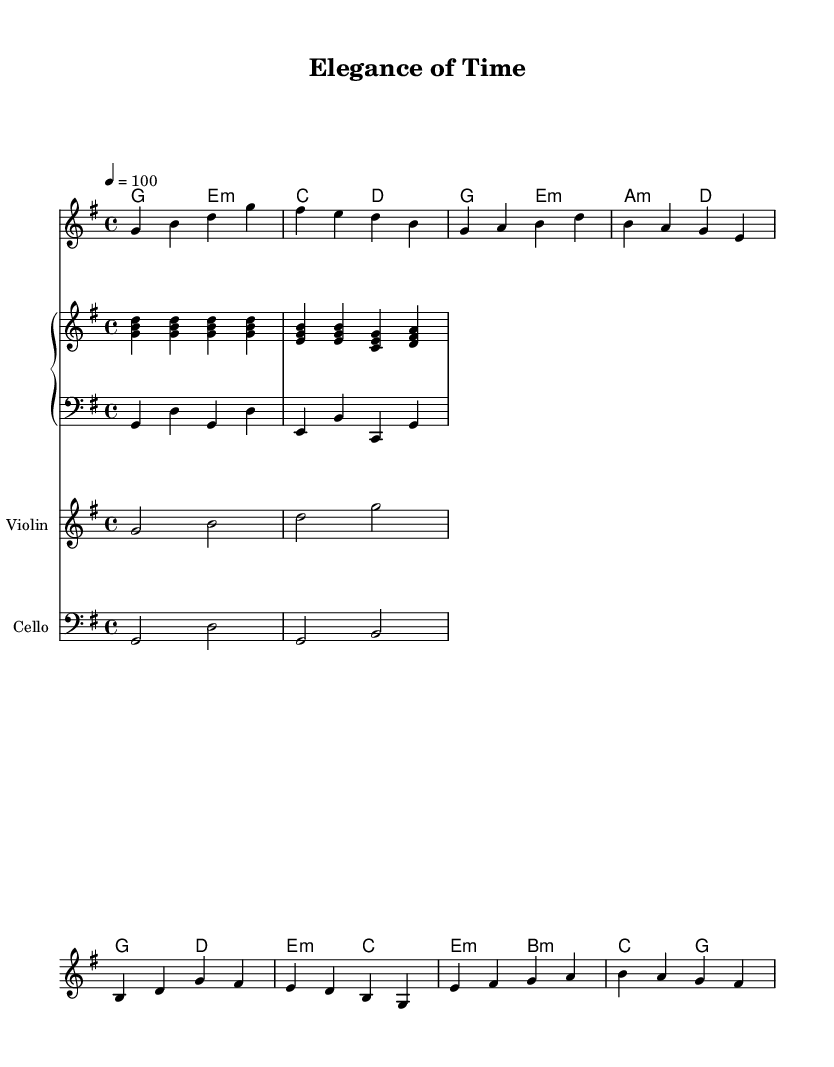What is the key signature of this music? The key signature indicates the presence of one sharp (F#), which means the music is in G major.
Answer: G major What is the time signature of this music? The time signature shows a 4/4 indication, meaning there are four beats per measure.
Answer: 4/4 What is the tempo marking of the piece? Looking at the tempo, it shows a quarter note equaling 100 beats per minute, signifying the pace of the piece.
Answer: 100 What is the structure of the melody based on the sections? The melody consists of an intro, verse 1, chorus, and a bridge, showing distinct parts typical in K-Pop songs.
Answer: Intro, Verse, Chorus, Bridge What instruments are featured in this arrangement? The arrangement includes a piano, violin, and cello, which complement the modern elements with classical sounds.
Answer: Piano, Violin, Cello How do the harmonies complement the melody? The harmonies laid out under the melody support it through a series of chords that fit well with the melody's notes, enhancing its emotional depth.
Answer: Supportive chords 